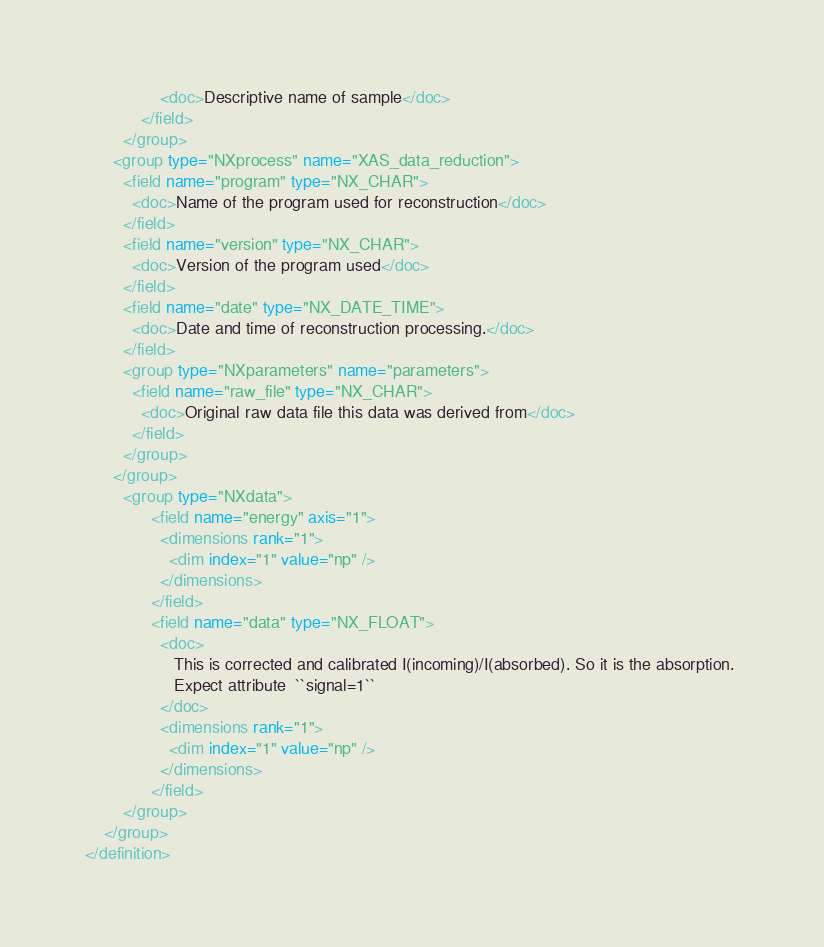<code> <loc_0><loc_0><loc_500><loc_500><_XML_>                <doc>Descriptive name of sample</doc>
            </field>
        </group>
      <group type="NXprocess" name="XAS_data_reduction">
        <field name="program" type="NX_CHAR">
          <doc>Name of the program used for reconstruction</doc>
        </field>
        <field name="version" type="NX_CHAR">
          <doc>Version of the program used</doc>
        </field>
        <field name="date" type="NX_DATE_TIME">
          <doc>Date and time of reconstruction processing.</doc>
        </field>
        <group type="NXparameters" name="parameters">
          <field name="raw_file" type="NX_CHAR">
            <doc>Original raw data file this data was derived from</doc>
          </field>
        </group>
      </group>
        <group type="NXdata">
              <field name="energy" axis="1">
                <dimensions rank="1">
                  <dim index="1" value="np" />
                </dimensions>
              </field>
              <field name="data" type="NX_FLOAT">
                <doc>
                   This is corrected and calibrated I(incoming)/I(absorbed). So it is the absorption. 
                   Expect attribute  ``signal=1``
                </doc>
                <dimensions rank="1">
                  <dim index="1" value="np" />
                </dimensions>
              </field>
        </group>
    </group>
</definition>
</code> 